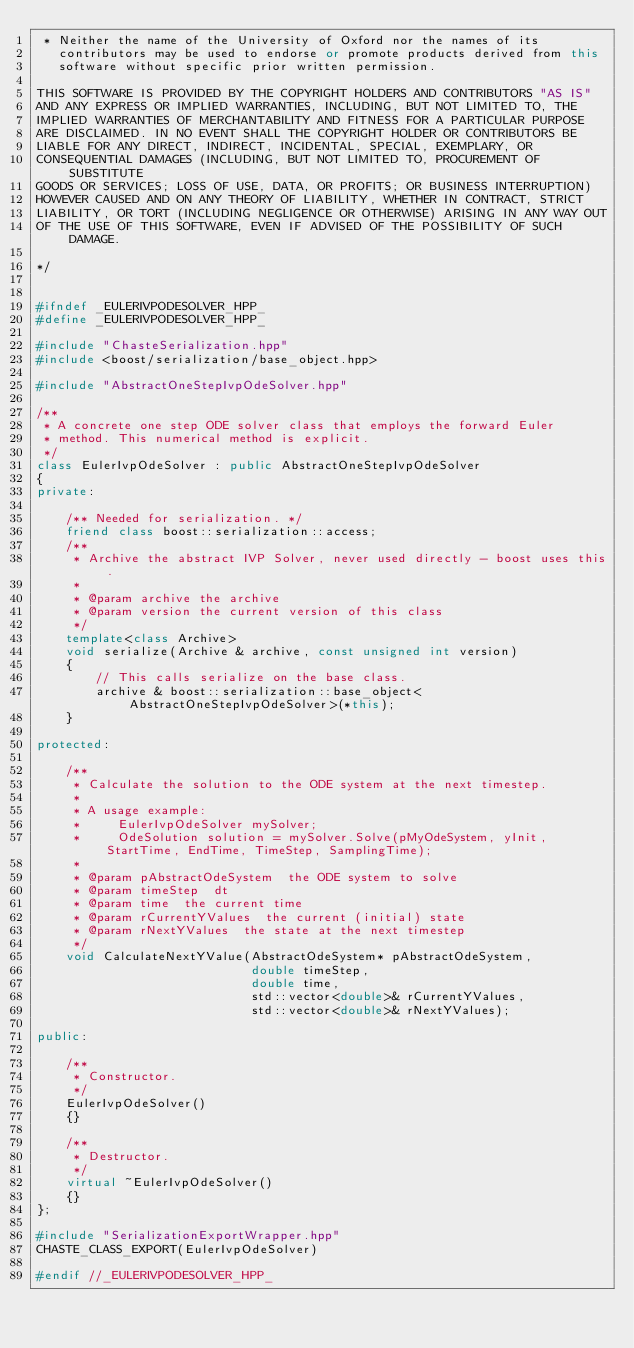Convert code to text. <code><loc_0><loc_0><loc_500><loc_500><_C++_> * Neither the name of the University of Oxford nor the names of its
   contributors may be used to endorse or promote products derived from this
   software without specific prior written permission.

THIS SOFTWARE IS PROVIDED BY THE COPYRIGHT HOLDERS AND CONTRIBUTORS "AS IS"
AND ANY EXPRESS OR IMPLIED WARRANTIES, INCLUDING, BUT NOT LIMITED TO, THE
IMPLIED WARRANTIES OF MERCHANTABILITY AND FITNESS FOR A PARTICULAR PURPOSE
ARE DISCLAIMED. IN NO EVENT SHALL THE COPYRIGHT HOLDER OR CONTRIBUTORS BE
LIABLE FOR ANY DIRECT, INDIRECT, INCIDENTAL, SPECIAL, EXEMPLARY, OR
CONSEQUENTIAL DAMAGES (INCLUDING, BUT NOT LIMITED TO, PROCUREMENT OF SUBSTITUTE
GOODS OR SERVICES; LOSS OF USE, DATA, OR PROFITS; OR BUSINESS INTERRUPTION)
HOWEVER CAUSED AND ON ANY THEORY OF LIABILITY, WHETHER IN CONTRACT, STRICT
LIABILITY, OR TORT (INCLUDING NEGLIGENCE OR OTHERWISE) ARISING IN ANY WAY OUT
OF THE USE OF THIS SOFTWARE, EVEN IF ADVISED OF THE POSSIBILITY OF SUCH DAMAGE.

*/


#ifndef _EULERIVPODESOLVER_HPP_
#define _EULERIVPODESOLVER_HPP_

#include "ChasteSerialization.hpp"
#include <boost/serialization/base_object.hpp>

#include "AbstractOneStepIvpOdeSolver.hpp"

/**
 * A concrete one step ODE solver class that employs the forward Euler
 * method. This numerical method is explicit.
 */
class EulerIvpOdeSolver : public AbstractOneStepIvpOdeSolver
{
private:

    /** Needed for serialization. */
    friend class boost::serialization::access;
    /**
     * Archive the abstract IVP Solver, never used directly - boost uses this.
     *
     * @param archive the archive
     * @param version the current version of this class
     */
    template<class Archive>
    void serialize(Archive & archive, const unsigned int version)
    {
        // This calls serialize on the base class.
        archive & boost::serialization::base_object<AbstractOneStepIvpOdeSolver>(*this);
    }

protected:

    /**
     * Calculate the solution to the ODE system at the next timestep.
     *
     * A usage example:
     *     EulerIvpOdeSolver mySolver;
     *     OdeSolution solution = mySolver.Solve(pMyOdeSystem, yInit, StartTime, EndTime, TimeStep, SamplingTime);
     *
     * @param pAbstractOdeSystem  the ODE system to solve
     * @param timeStep  dt
     * @param time  the current time
     * @param rCurrentYValues  the current (initial) state
     * @param rNextYValues  the state at the next timestep
     */
    void CalculateNextYValue(AbstractOdeSystem* pAbstractOdeSystem,
                             double timeStep,
                             double time,
                             std::vector<double>& rCurrentYValues,
                             std::vector<double>& rNextYValues);

public:

    /**
     * Constructor.
     */
    EulerIvpOdeSolver()
    {}

    /**
     * Destructor.
     */
    virtual ~EulerIvpOdeSolver()
    {}
};

#include "SerializationExportWrapper.hpp"
CHASTE_CLASS_EXPORT(EulerIvpOdeSolver)

#endif //_EULERIVPODESOLVER_HPP_

</code> 